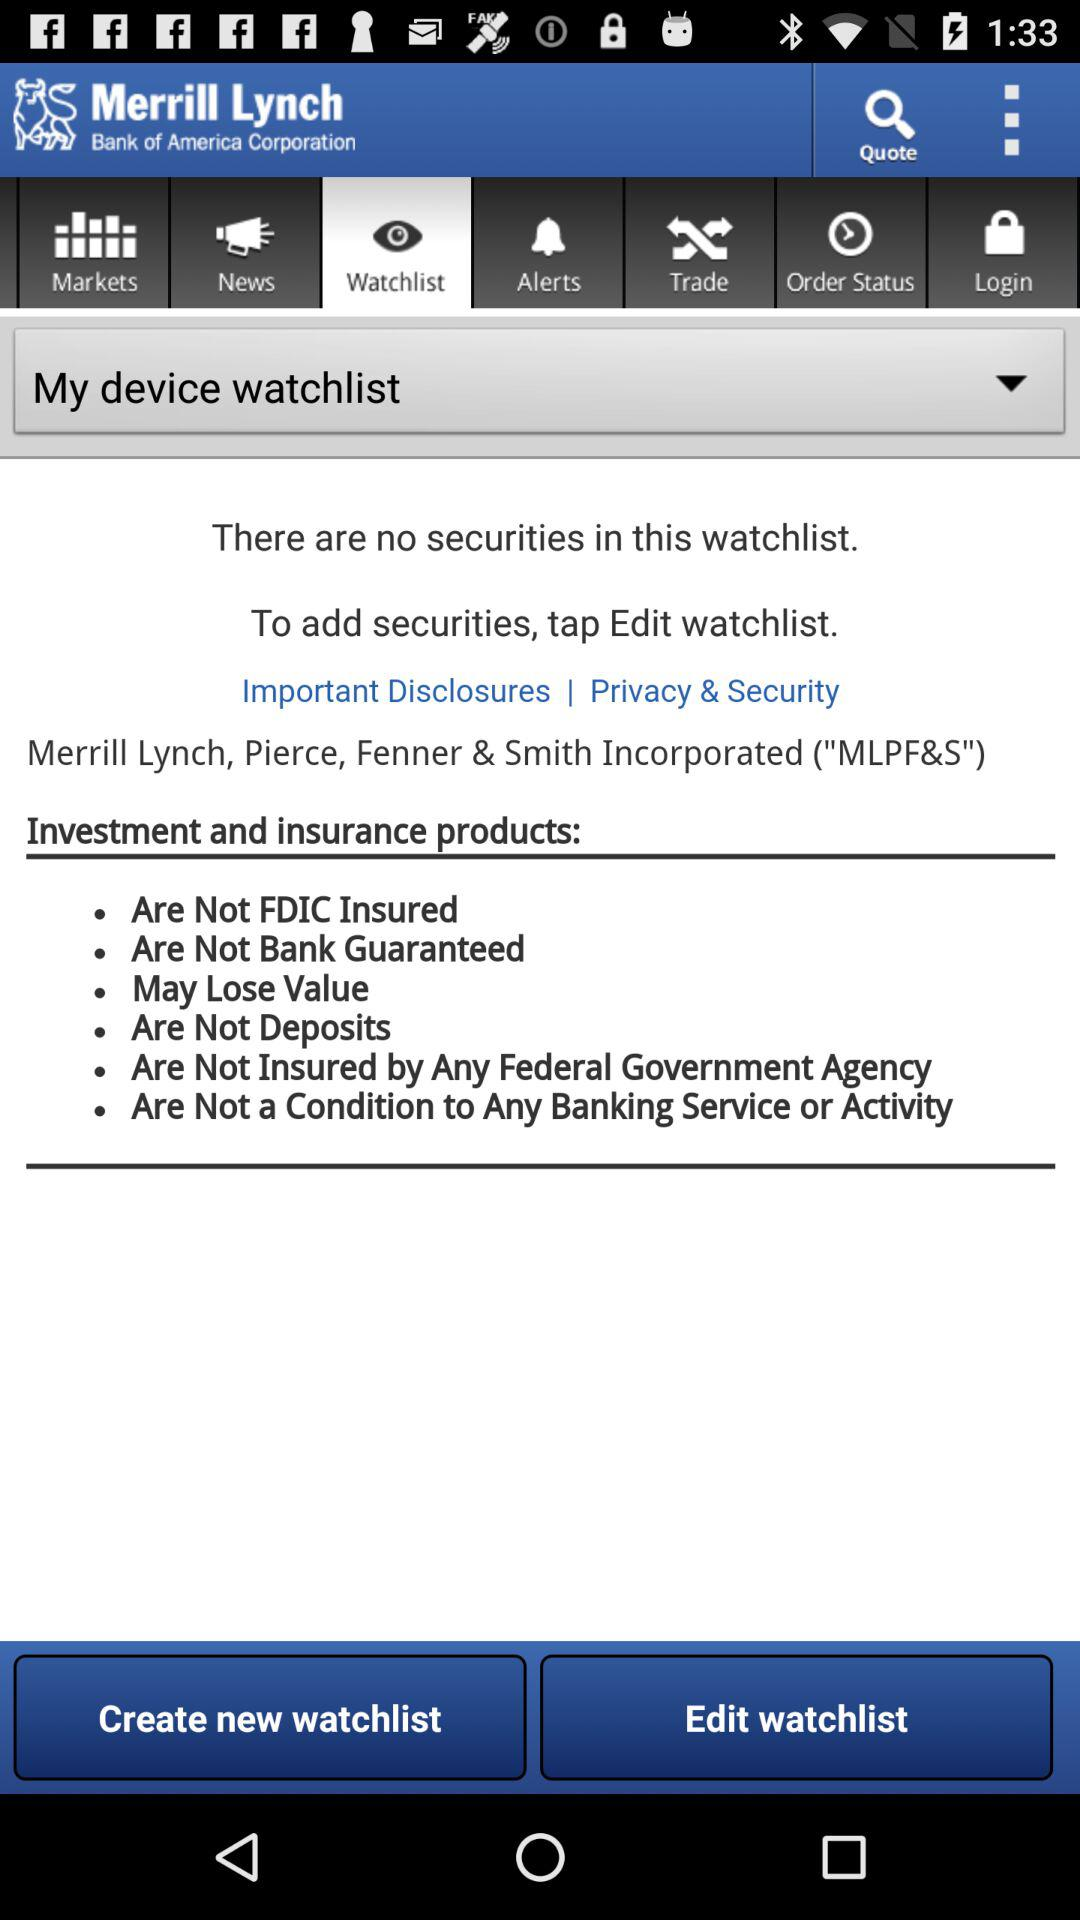Which tab is selected? The selected tab is "Watchlist". 